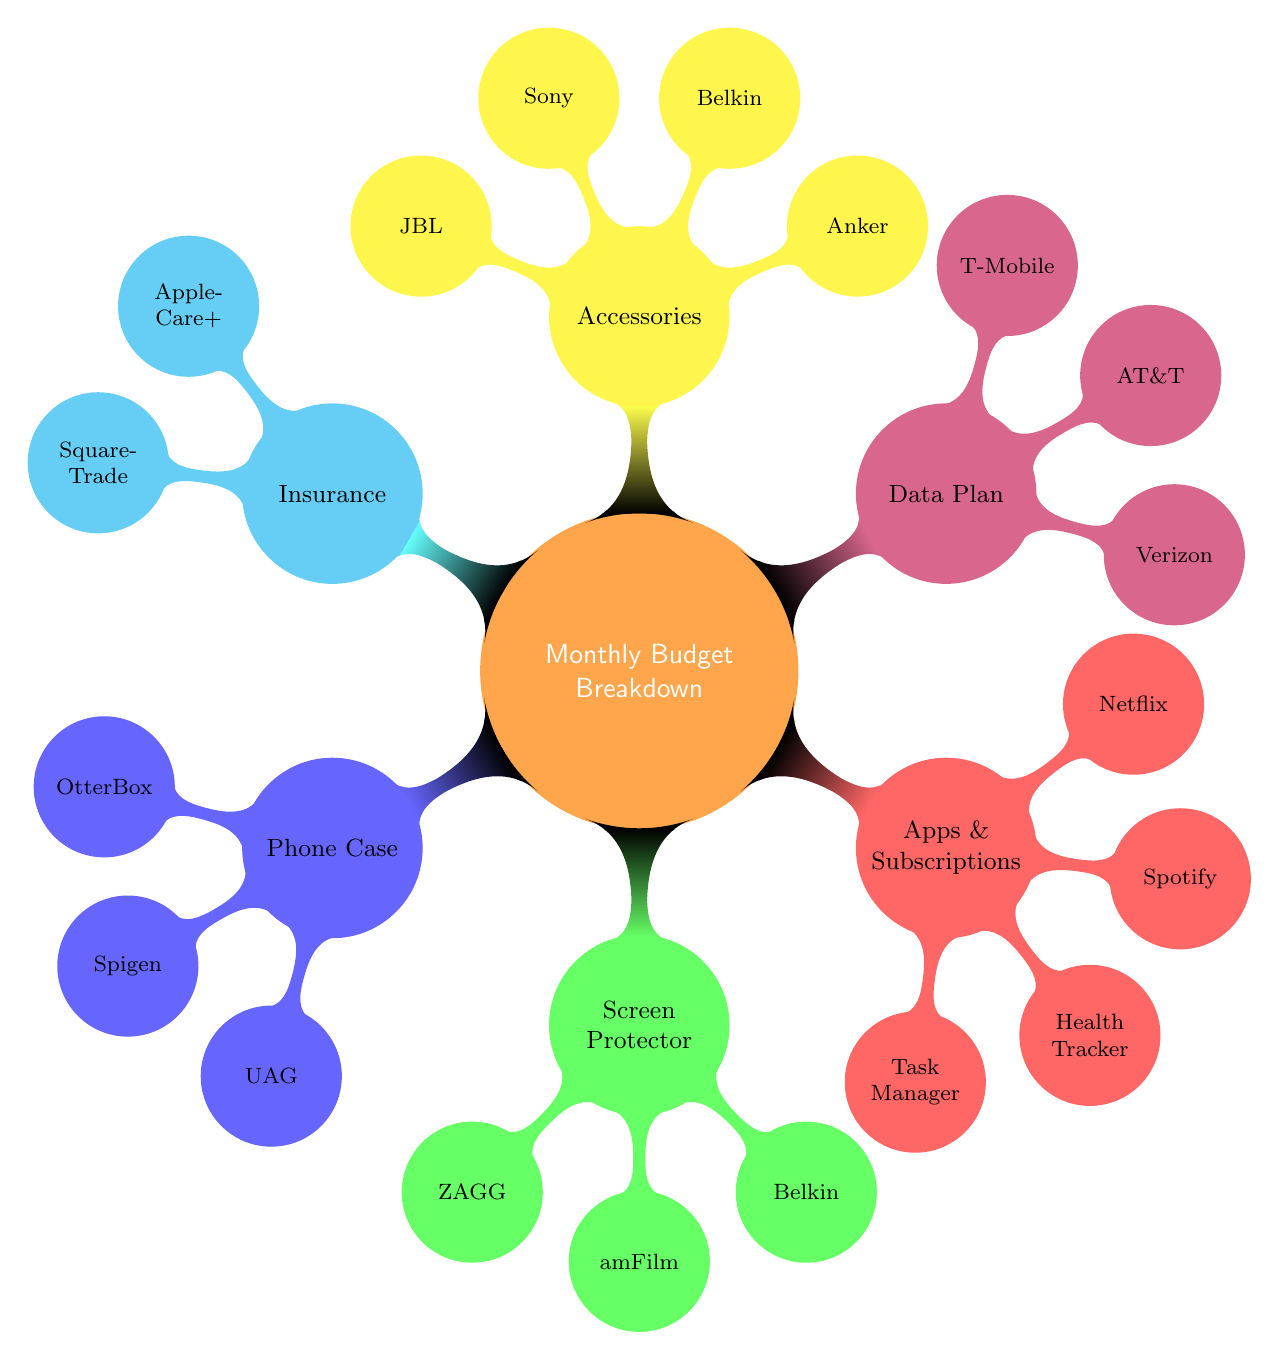What are the three brands under Phone Case? The diagram lists three brands associated with Phone Case, which are OtterBox, Spigen, and UAG. These brands are directly placed as children nodes under the Phone Case node.
Answer: OtterBox, Spigen, UAG How many nodes are listed under Apps and Subscriptions? In the diagram, Apps and Subscriptions has four total nodes listed: Task Manager, Health Tracker, Spotify, and Netflix, which are child nodes under this category. Thus, the count of nodes is four.
Answer: 4 Which two plans are available for Insurance? The diagram provides two plans listed under Insurance, which are AppleCare+ and SquareTrade. This information is found as child nodes stemming from the Insurance node.
Answer: AppleCare+, SquareTrade What is the monthly cost associated with T-Mobile? The diagram shows that T-Mobile is included in the Data Plan section, but it does not explicitly state the monthly cost for T-Mobile; instead, it only lists three costs (Verizon: $60, AT&T: $80, T-Mobile: $100) as child nodes under the Data Plan node. Thus, T-Mobile's cost is inferred to be $100.
Answer: $100 List three accessory brands mentioned. The node Accessories has four child nodes, which represent different accessory brands: Anker, Belkin, Sony, and JBL. Hence, three of the brands listed can be any combination taken from this group; a sample would be Anker, Belkin, Sony.
Answer: Anker, Belkin, Sony What brands of screen protector are shown? The diagram specifically lists three brands under the Screen Protector node: ZAGG, amFilm, and Belkin. These are depicted as child nodes under the Screen Protector category.
Answer: ZAGG, amFilm, Belkin Which mobile network has the lowest monthly cost? Analyzing the Data Plan section of the diagram, it mentions three mobile networks with their respective monthly costs. Verizon has $60, AT&T has $80, and T-Mobile has $100. The lowest among these is Verizon with a cost of $60.
Answer: Verizon Identify the subscription services mentioned. There are two subscription services listed under the Apps and Subscriptions node: Spotify and Netflix. These are child nodes, indicating they fall under the category of subscription services.
Answer: Spotify, Netflix 